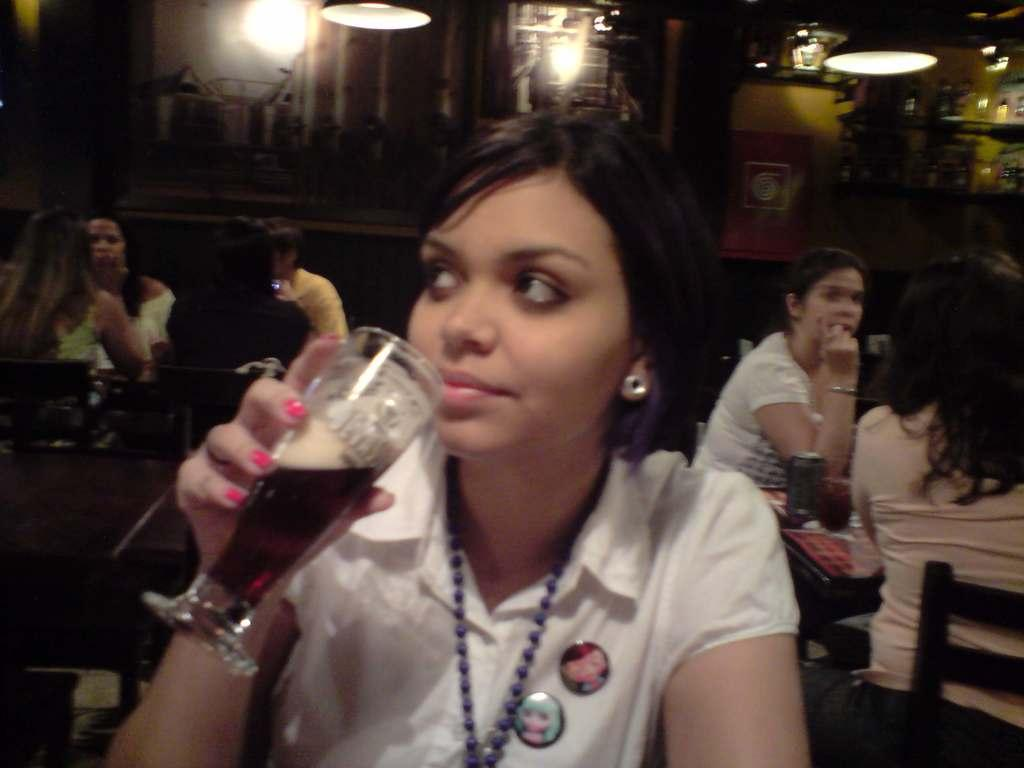What are the people in the image doing? There is a group of people sitting in the image. Can you describe the person in front? The person in front is wearing a white dress. What is the person in front holding? The person in front is holding a glass. What can be seen in the background of the image? There are lights visible in the background of the image. What type of houses can be seen in the image? There are no houses present in the image. How does the person in the white dress use their mind to smash the glass? The person in the white dress is not using their mind to smash the glass, as they are holding it in the image. 